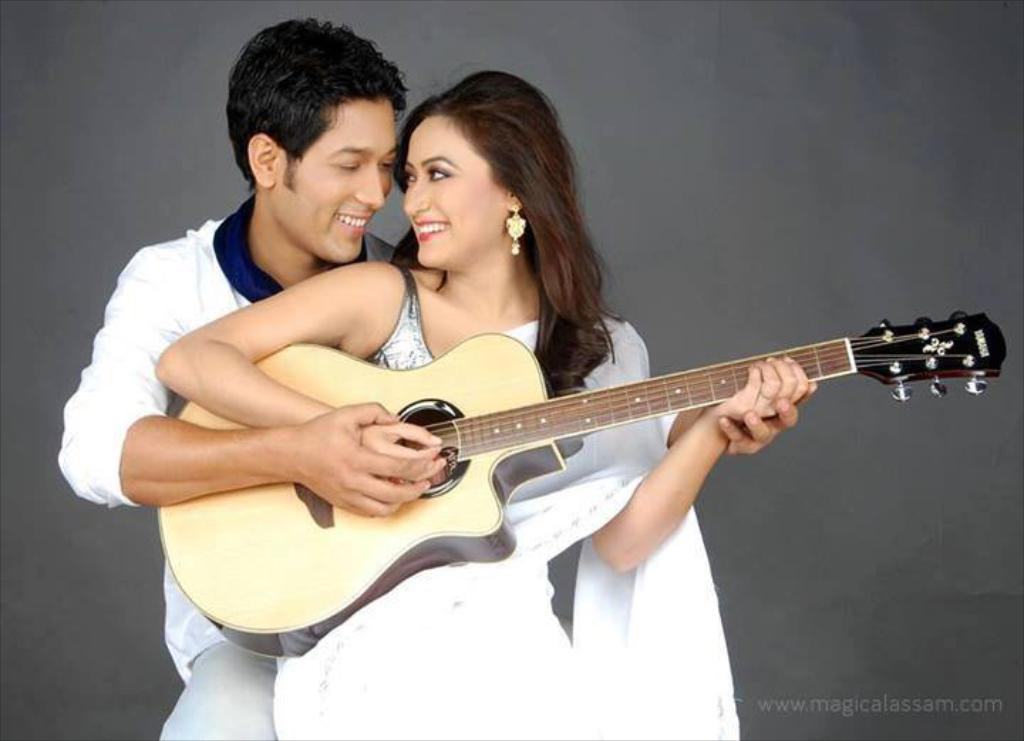How many people are present in the image? There are two people in the image, a man and a woman. What are the people in the image doing? The man and the woman are playing guitar. What expressions do the people in the image have? Both the man and the woman are smiling. What type of houses can be seen in the background of the image? There is no background or houses present in the image; it only features the man and the woman playing guitar. What committee is responsible for organizing the event in the image? There is no event or committee present in the image; it only features the man and the woman playing guitar. 